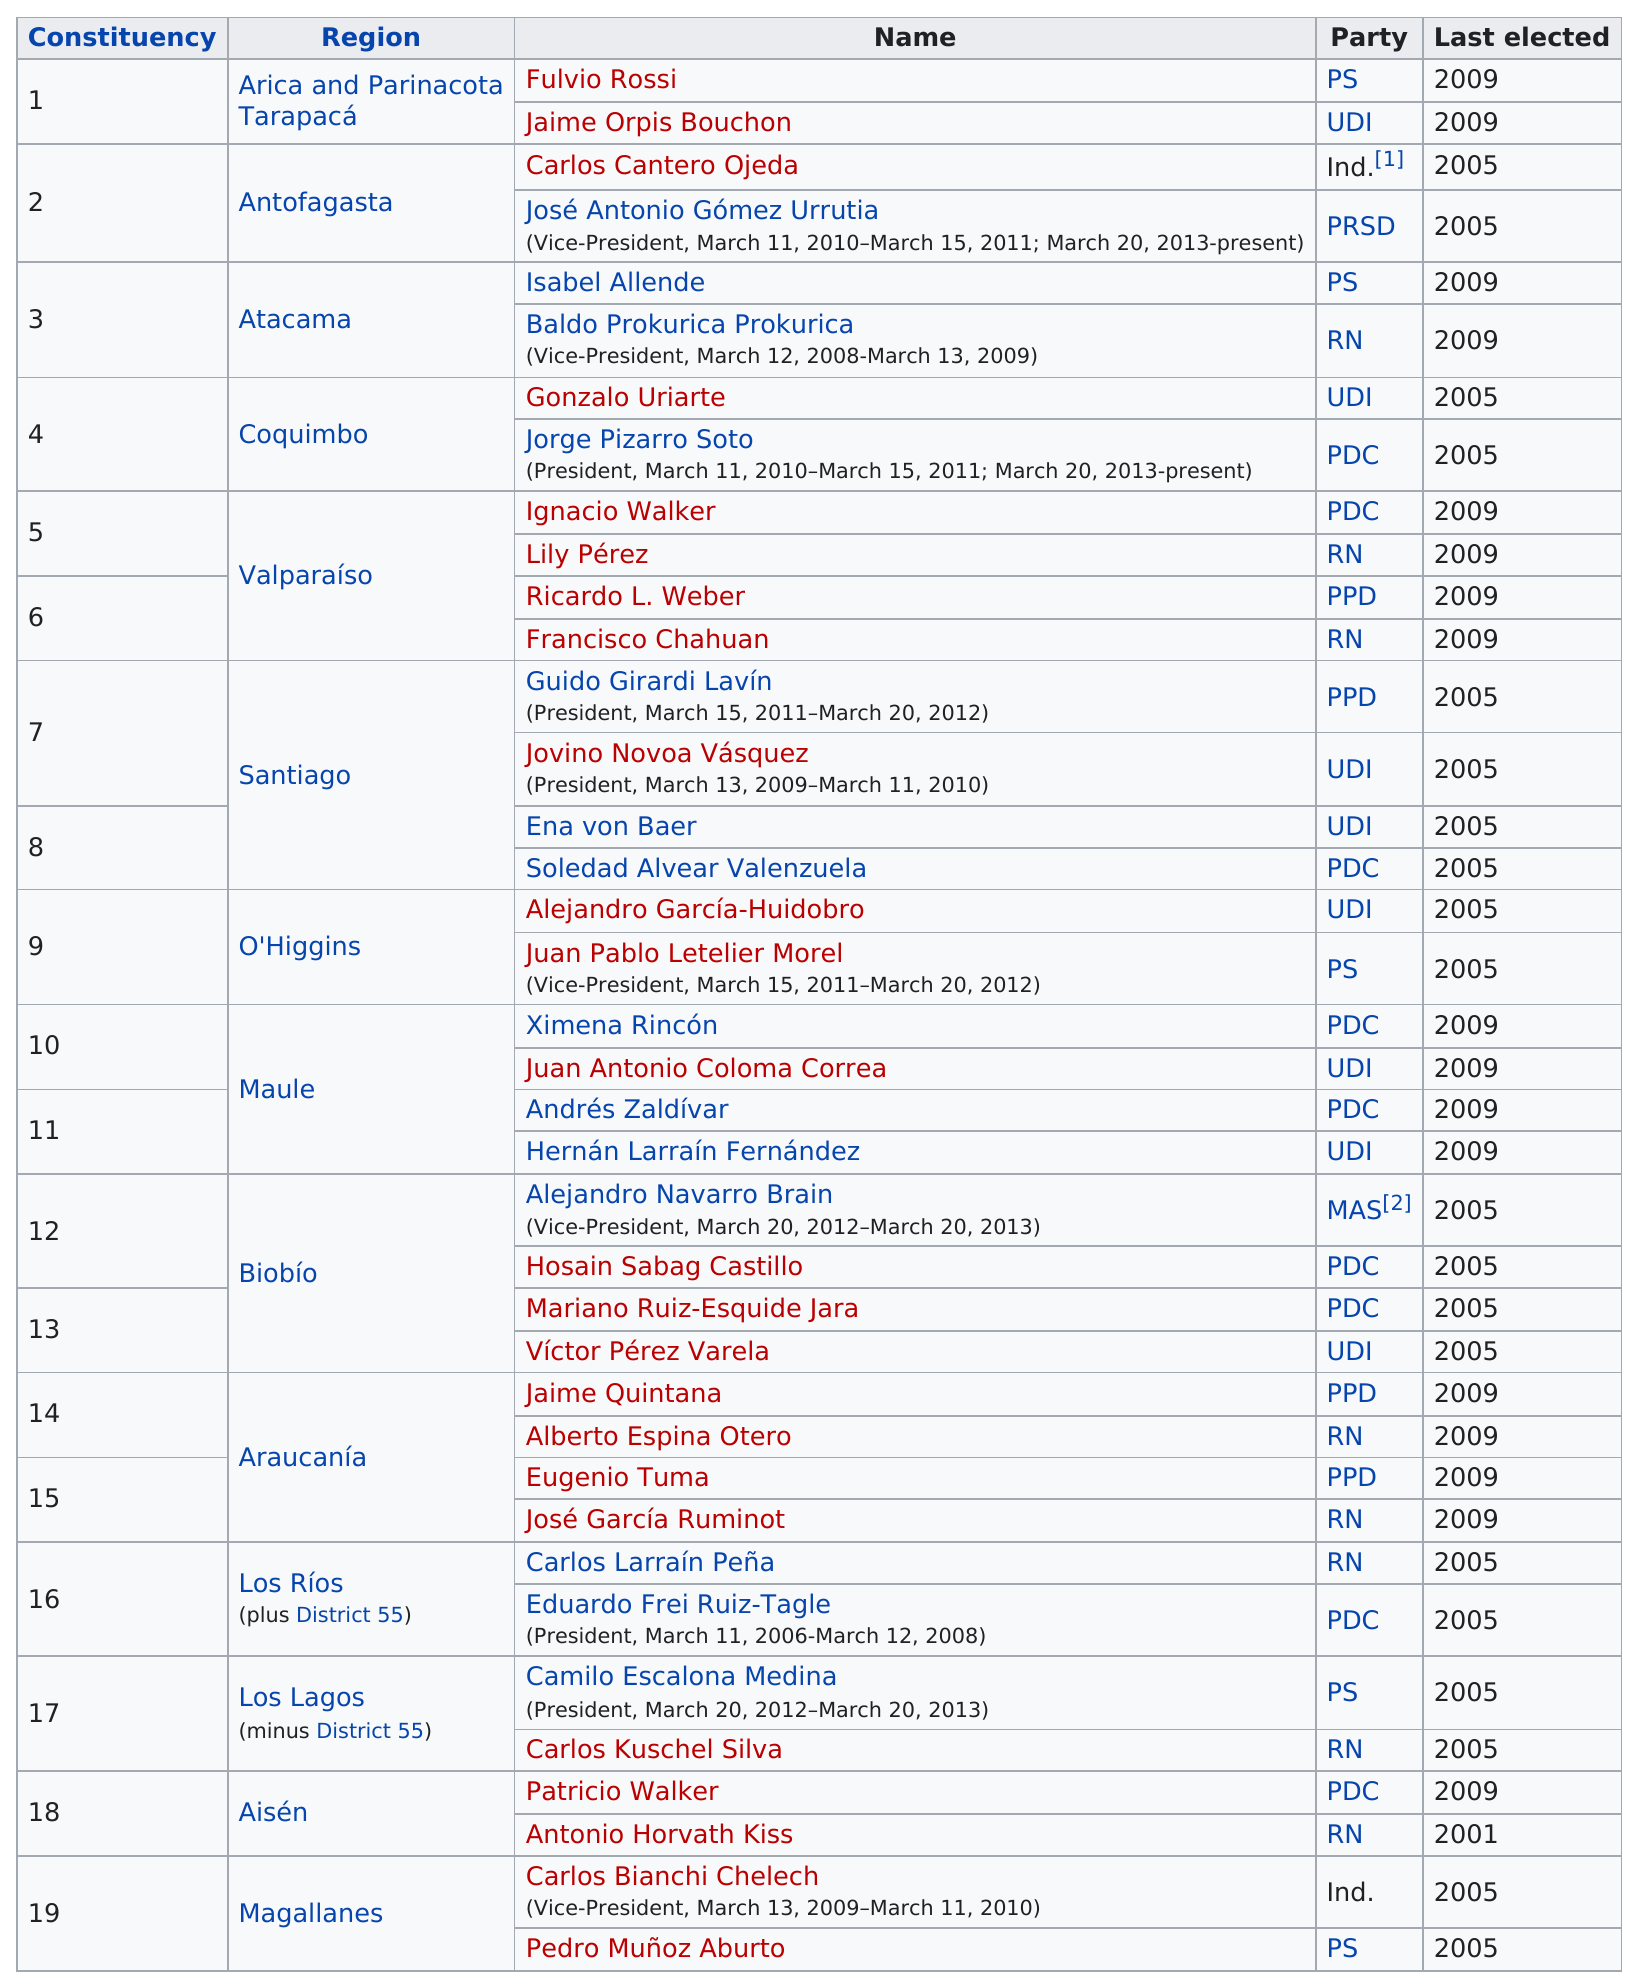Point out several critical features in this image. In the year 2001, Antonio Horvath was elected for the first time. The region listed as "Magallanes" is the last region on the table. Baldo Prokurica served as Vice President for a period of one year. In 2001, Antonio Horvath was last elected. Jaime Quintana was a member of the PPD political party. 